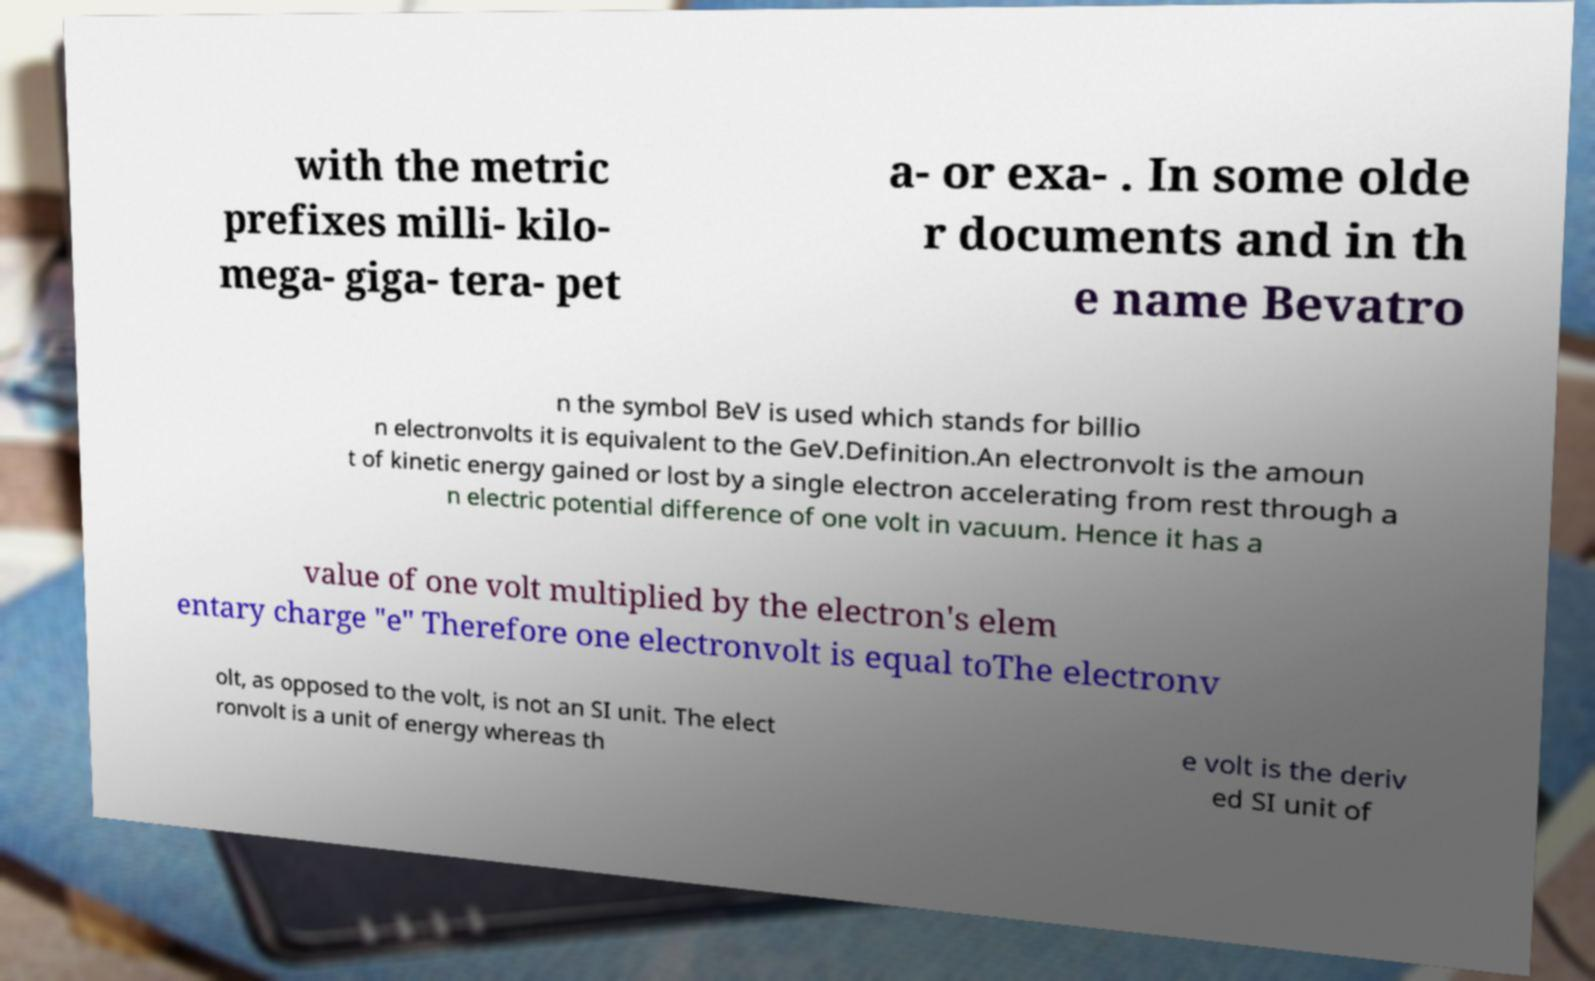Please read and relay the text visible in this image. What does it say? with the metric prefixes milli- kilo- mega- giga- tera- pet a- or exa- . In some olde r documents and in th e name Bevatro n the symbol BeV is used which stands for billio n electronvolts it is equivalent to the GeV.Definition.An electronvolt is the amoun t of kinetic energy gained or lost by a single electron accelerating from rest through a n electric potential difference of one volt in vacuum. Hence it has a value of one volt multiplied by the electron's elem entary charge "e" Therefore one electronvolt is equal toThe electronv olt, as opposed to the volt, is not an SI unit. The elect ronvolt is a unit of energy whereas th e volt is the deriv ed SI unit of 